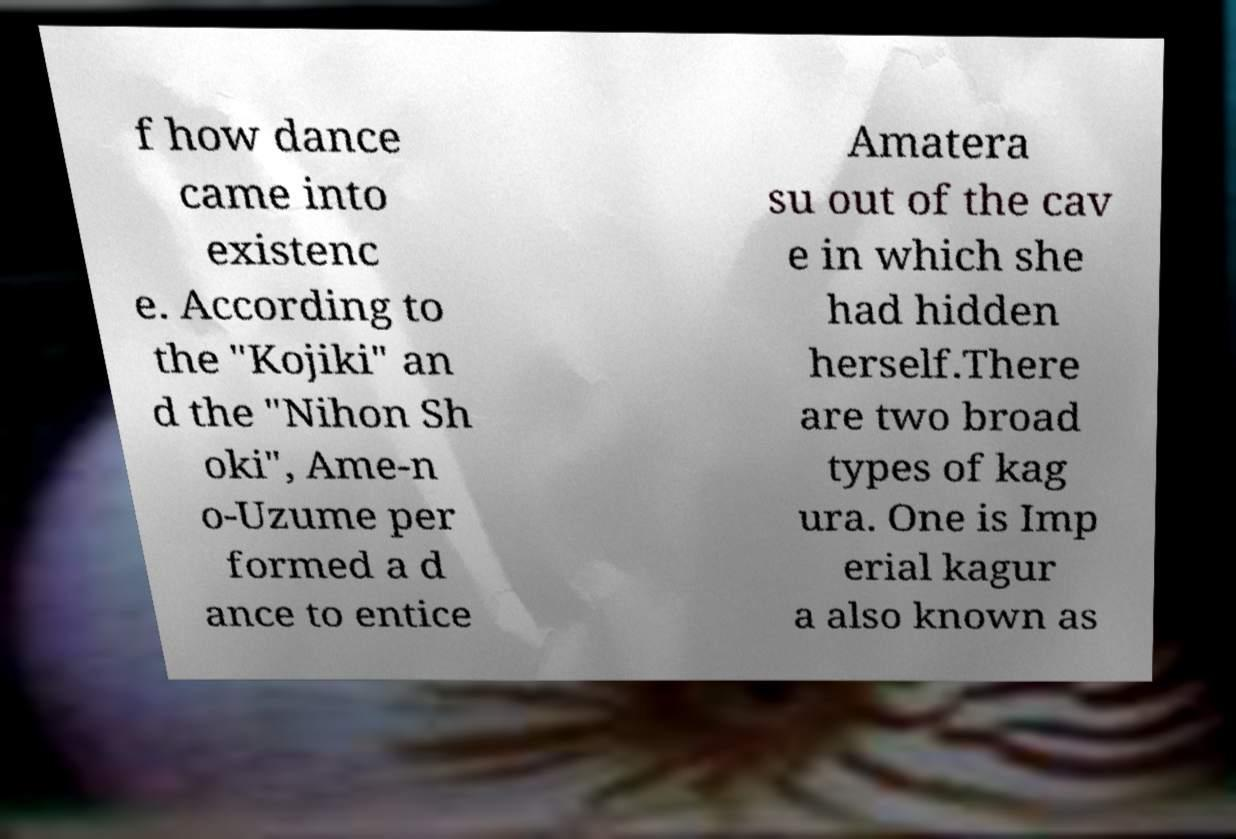Please identify and transcribe the text found in this image. f how dance came into existenc e. According to the "Kojiki" an d the "Nihon Sh oki", Ame-n o-Uzume per formed a d ance to entice Amatera su out of the cav e in which she had hidden herself.There are two broad types of kag ura. One is Imp erial kagur a also known as 